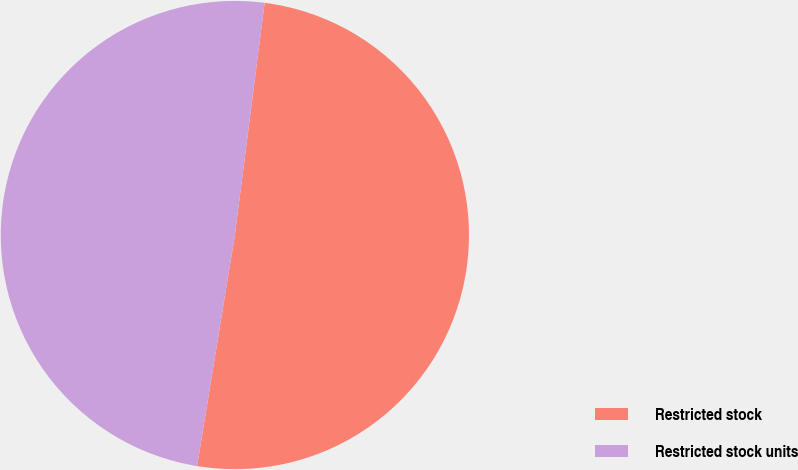Convert chart to OTSL. <chart><loc_0><loc_0><loc_500><loc_500><pie_chart><fcel>Restricted stock<fcel>Restricted stock units<nl><fcel>50.55%<fcel>49.45%<nl></chart> 